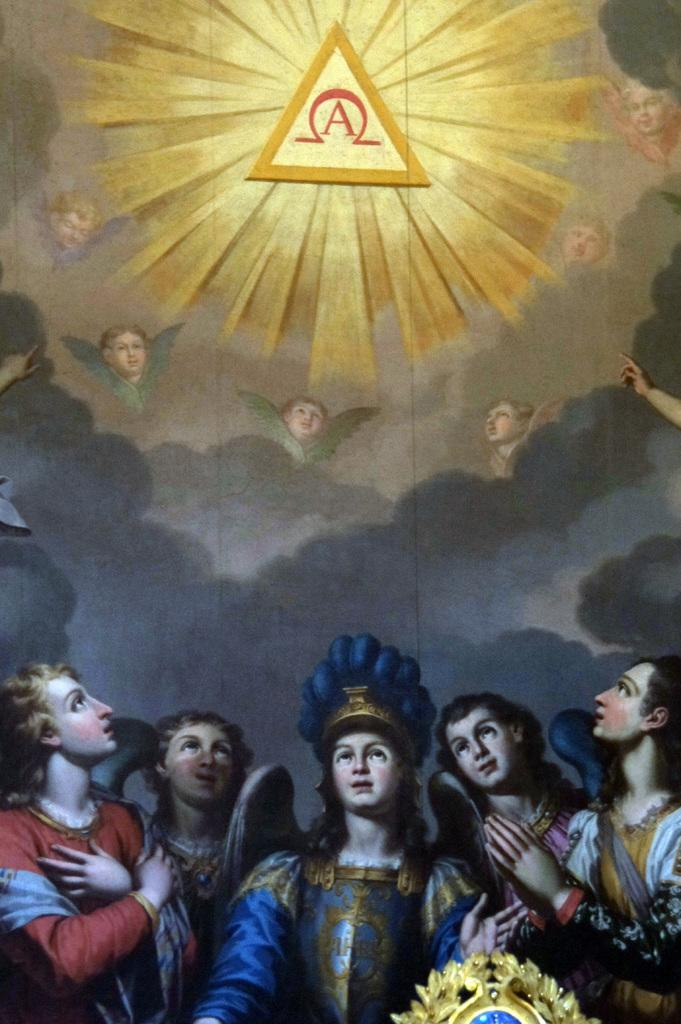What type of artwork is shown in the image? The image is a painting. What subjects are depicted in the painting? There are persons depicted in the painting. What can be seen in the background of the painting? There are clouds in the background of the painting. How many cubs are playing with the persons in the painting? There are no cubs present in the painting; it depicts persons and clouds in the background. What color is the tongue of the girl in the painting? There are no girls depicted in the painting, and therefore no tongue to describe. 